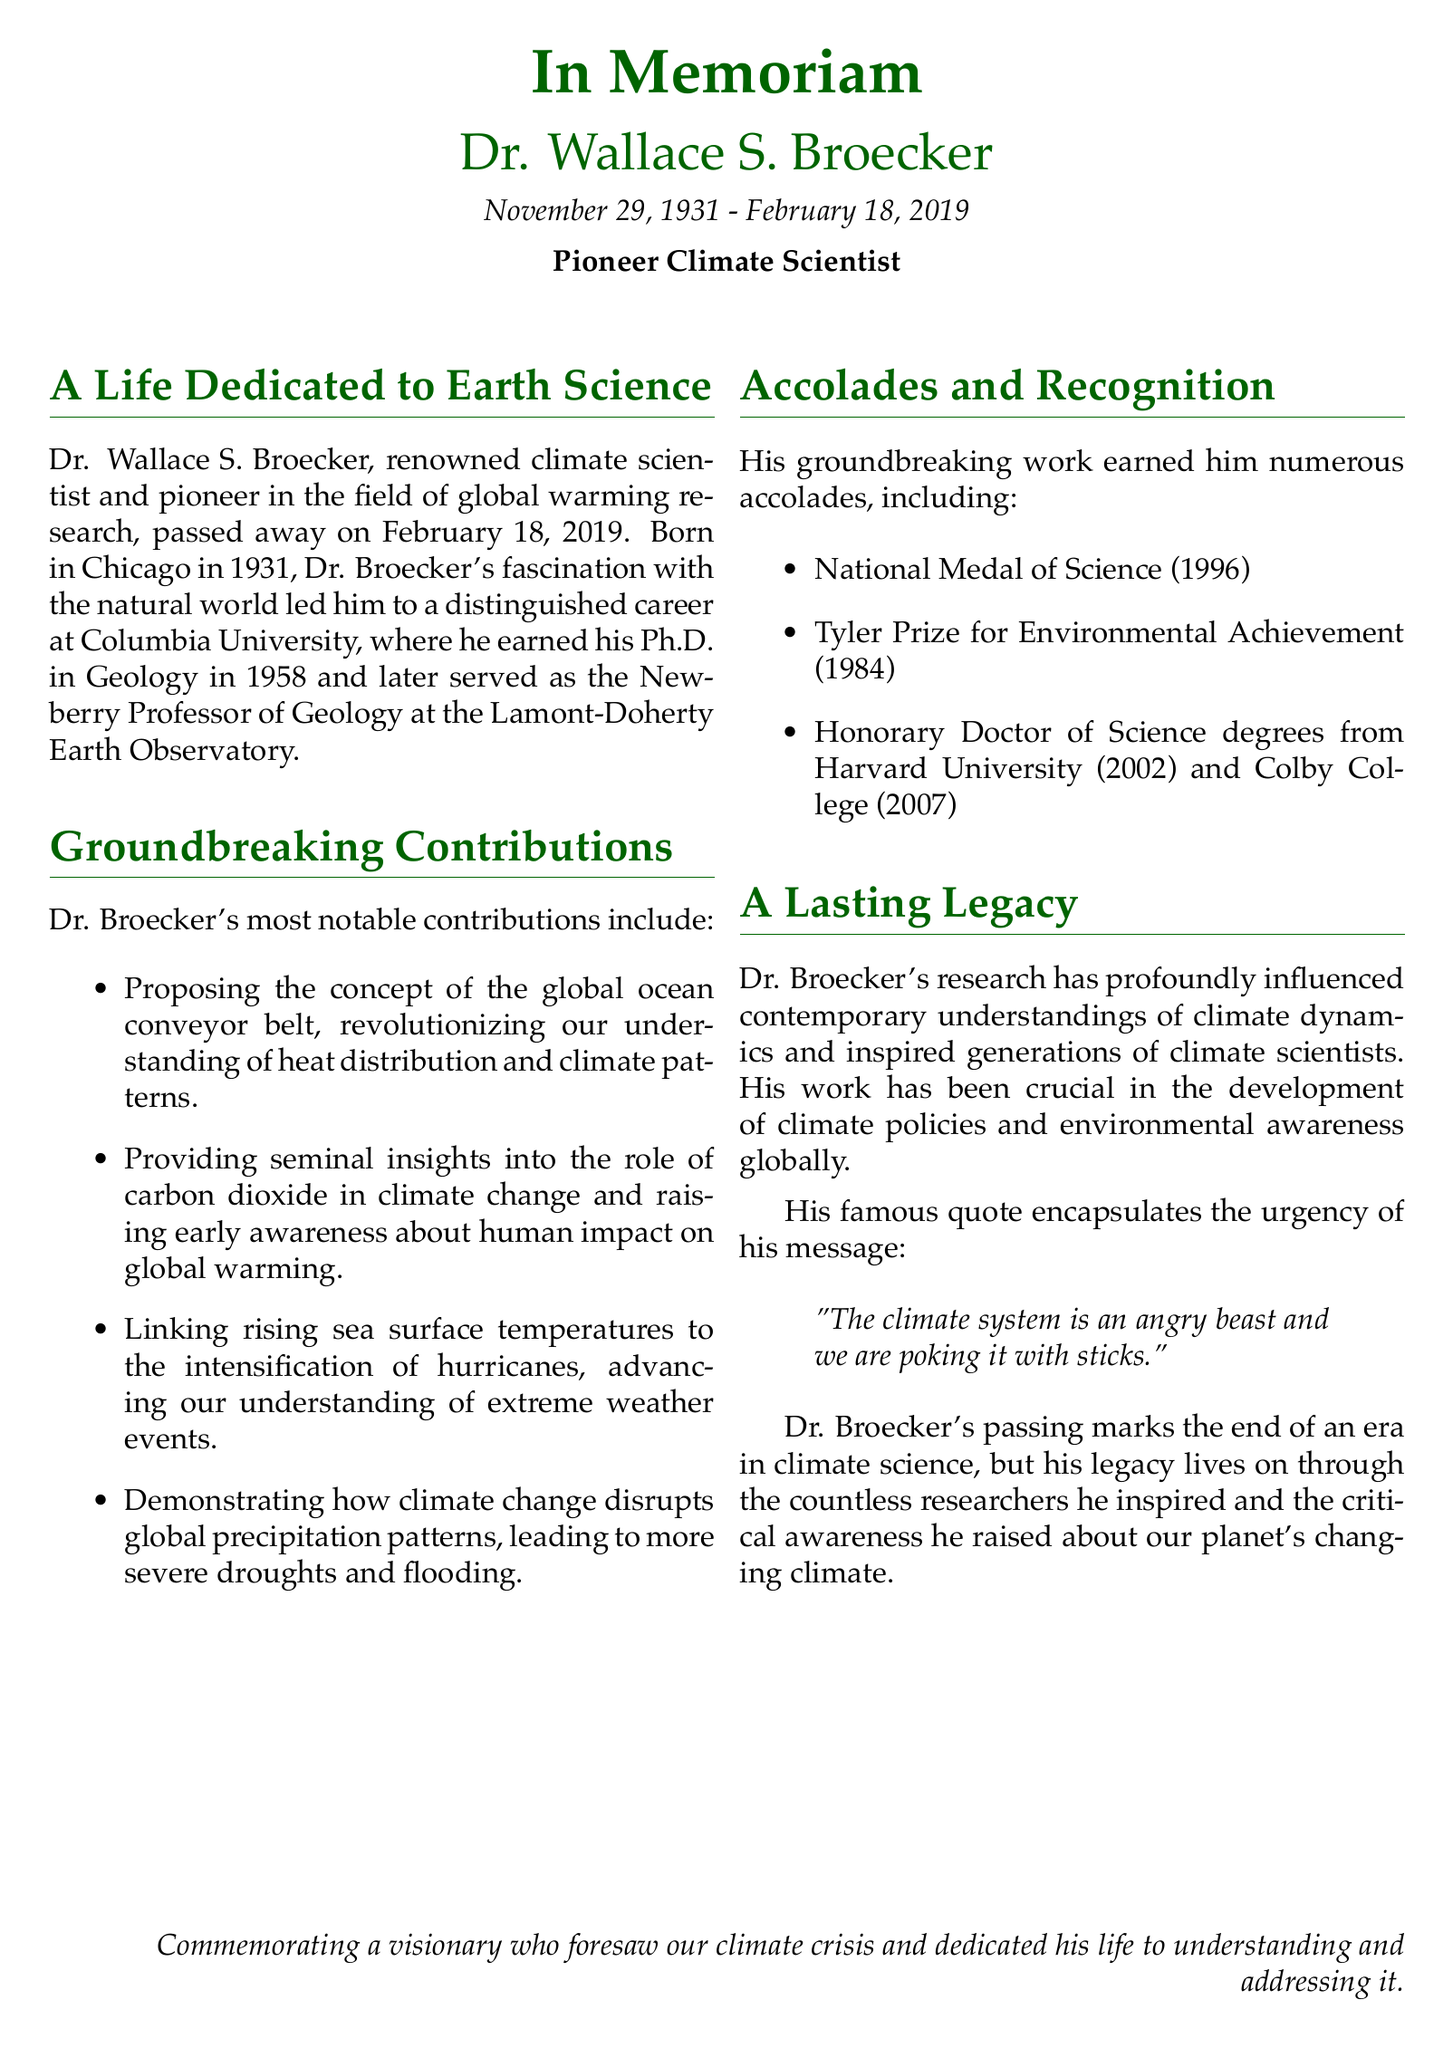What is the full name of the climate scientist commemorated? The document names Dr. Wallace S. Broecker as the commemorated climate scientist.
Answer: Dr. Wallace S. Broecker What was the year Dr. Broecker earned his Ph.D.? The document states that Dr. Broecker earned his Ph.D. in Geology in 1958.
Answer: 1958 Which prestigious award did he receive in 1996? The document mentions that he received the National Medal of Science in 1996.
Answer: National Medal of Science What theory did Dr. Broecker propose that changed understanding of heat distribution? The document notes that he proposed the concept of the global ocean conveyor belt.
Answer: global ocean conveyor belt What significant link did Dr. Broecker make regarding extreme weather events? The document states he linked rising sea surface temperatures to the intensification of hurricanes.
Answer: intensification of hurricanes Name the university where Dr. Broecker spent a significant part of his career. The document highlights Columbia University as the university where Dr. Broecker worked.
Answer: Columbia University Which quote from Dr. Broecker underscores the urgency of climate change? The document includes a famous quote by Dr. BroeckerWarning about the climate system.
Answer: "The climate system is an angry beast and we are poking it with sticks." What is the significance of Dr. Broecker's work as mentioned in this obituary? The document explains his work has profoundly influenced contemporary understandings of climate dynamics.
Answer: influenced contemporary understandings of climate dynamics What year did Dr. Broecker pass away? The document specifies that he passed away on February 18, 2019.
Answer: February 18, 2019 